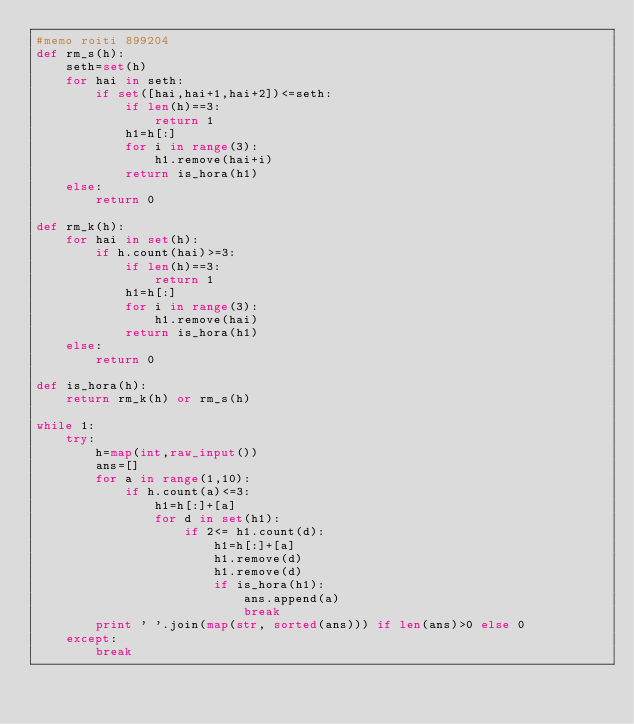<code> <loc_0><loc_0><loc_500><loc_500><_Python_>#memo roiti 899204
def rm_s(h):
    seth=set(h)
    for hai in seth:
        if set([hai,hai+1,hai+2])<=seth:
            if len(h)==3:
                return 1
            h1=h[:]
            for i in range(3):
                h1.remove(hai+i)
            return is_hora(h1)
    else:
        return 0

def rm_k(h):
    for hai in set(h):
        if h.count(hai)>=3:
            if len(h)==3:
                return 1
            h1=h[:]
            for i in range(3):
                h1.remove(hai)
            return is_hora(h1)
    else:
        return 0

def is_hora(h):
    return rm_k(h) or rm_s(h)

while 1:
    try:
        h=map(int,raw_input())
        ans=[]
        for a in range(1,10):
            if h.count(a)<=3:
                h1=h[:]+[a]
                for d in set(h1):
                    if 2<= h1.count(d):
                        h1=h[:]+[a]
                        h1.remove(d)
                        h1.remove(d)
                        if is_hora(h1):
                            ans.append(a)
                            break
        print ' '.join(map(str, sorted(ans))) if len(ans)>0 else 0
    except:
        break</code> 